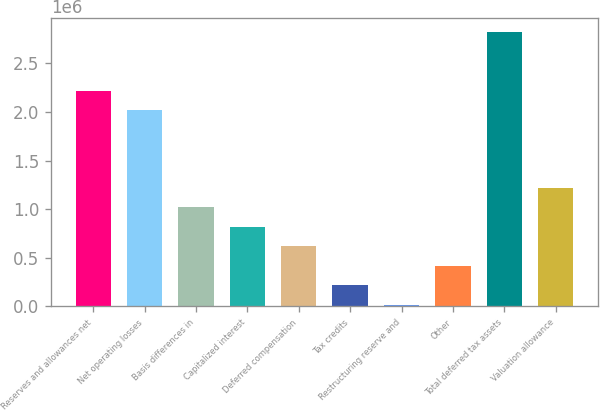Convert chart to OTSL. <chart><loc_0><loc_0><loc_500><loc_500><bar_chart><fcel>Reserves and allowances net<fcel>Net operating losses<fcel>Basis differences in<fcel>Capitalized interest<fcel>Deferred compensation<fcel>Tax credits<fcel>Restructuring reserve and<fcel>Other<fcel>Total deferred tax assets<fcel>Valuation allowance<nl><fcel>2.2212e+06<fcel>2.02065e+06<fcel>1.01787e+06<fcel>817314<fcel>616759<fcel>215648<fcel>15092<fcel>416203<fcel>2.82287e+06<fcel>1.21843e+06<nl></chart> 